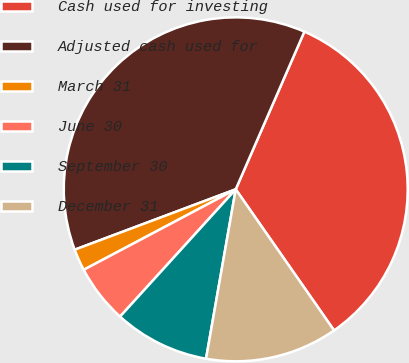Convert chart to OTSL. <chart><loc_0><loc_0><loc_500><loc_500><pie_chart><fcel>Cash used for investing<fcel>Adjusted cash used for<fcel>March 31<fcel>June 30<fcel>September 30<fcel>December 31<nl><fcel>33.78%<fcel>37.25%<fcel>2.04%<fcel>5.51%<fcel>8.98%<fcel>12.45%<nl></chart> 